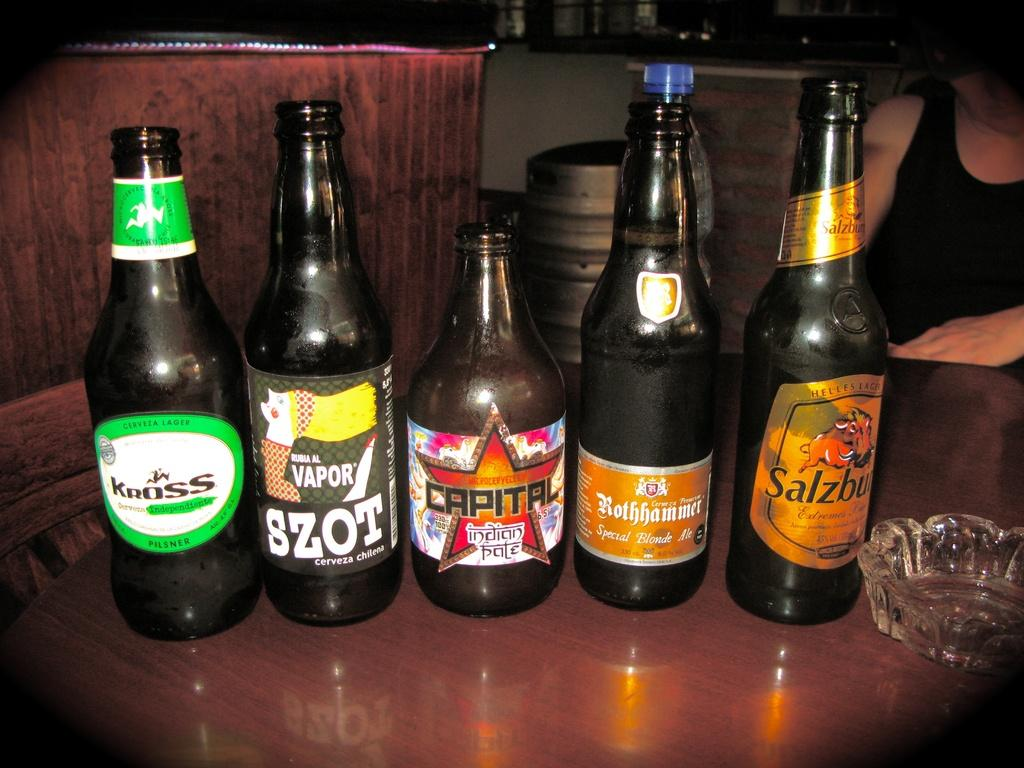<image>
Offer a succinct explanation of the picture presented. Five bottles of alcohol placed in a line with Capital being in the middle. 